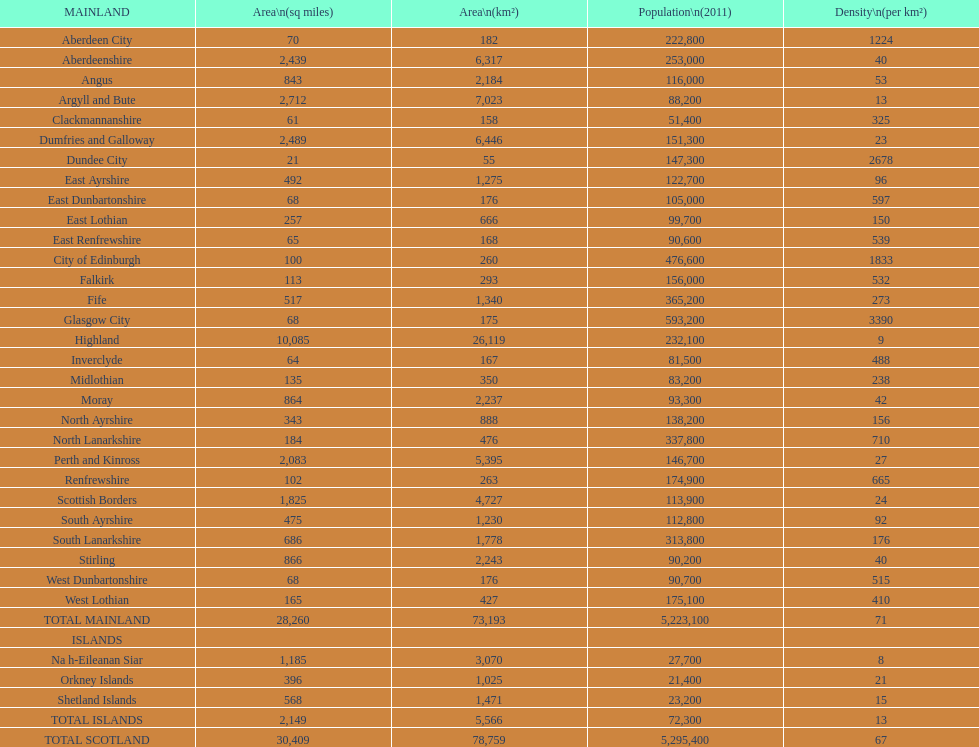I'm looking to parse the entire table for insights. Could you assist me with that? {'header': ['MAINLAND', 'Area\\n(sq miles)', 'Area\\n(km²)', 'Population\\n(2011)', 'Density\\n(per km²)'], 'rows': [['Aberdeen City', '70', '182', '222,800', '1224'], ['Aberdeenshire', '2,439', '6,317', '253,000', '40'], ['Angus', '843', '2,184', '116,000', '53'], ['Argyll and Bute', '2,712', '7,023', '88,200', '13'], ['Clackmannanshire', '61', '158', '51,400', '325'], ['Dumfries and Galloway', '2,489', '6,446', '151,300', '23'], ['Dundee City', '21', '55', '147,300', '2678'], ['East Ayrshire', '492', '1,275', '122,700', '96'], ['East Dunbartonshire', '68', '176', '105,000', '597'], ['East Lothian', '257', '666', '99,700', '150'], ['East Renfrewshire', '65', '168', '90,600', '539'], ['City of Edinburgh', '100', '260', '476,600', '1833'], ['Falkirk', '113', '293', '156,000', '532'], ['Fife', '517', '1,340', '365,200', '273'], ['Glasgow City', '68', '175', '593,200', '3390'], ['Highland', '10,085', '26,119', '232,100', '9'], ['Inverclyde', '64', '167', '81,500', '488'], ['Midlothian', '135', '350', '83,200', '238'], ['Moray', '864', '2,237', '93,300', '42'], ['North Ayrshire', '343', '888', '138,200', '156'], ['North Lanarkshire', '184', '476', '337,800', '710'], ['Perth and Kinross', '2,083', '5,395', '146,700', '27'], ['Renfrewshire', '102', '263', '174,900', '665'], ['Scottish Borders', '1,825', '4,727', '113,900', '24'], ['South Ayrshire', '475', '1,230', '112,800', '92'], ['South Lanarkshire', '686', '1,778', '313,800', '176'], ['Stirling', '866', '2,243', '90,200', '40'], ['West Dunbartonshire', '68', '176', '90,700', '515'], ['West Lothian', '165', '427', '175,100', '410'], ['TOTAL MAINLAND', '28,260', '73,193', '5,223,100', '71'], ['ISLANDS', '', '', '', ''], ['Na h-Eileanan Siar', '1,185', '3,070', '27,700', '8'], ['Orkney Islands', '396', '1,025', '21,400', '21'], ['Shetland Islands', '568', '1,471', '23,200', '15'], ['TOTAL ISLANDS', '2,149', '5,566', '72,300', '13'], ['TOTAL SCOTLAND', '30,409', '78,759', '5,295,400', '67']]} Which continent has the smallest population? Clackmannanshire. 